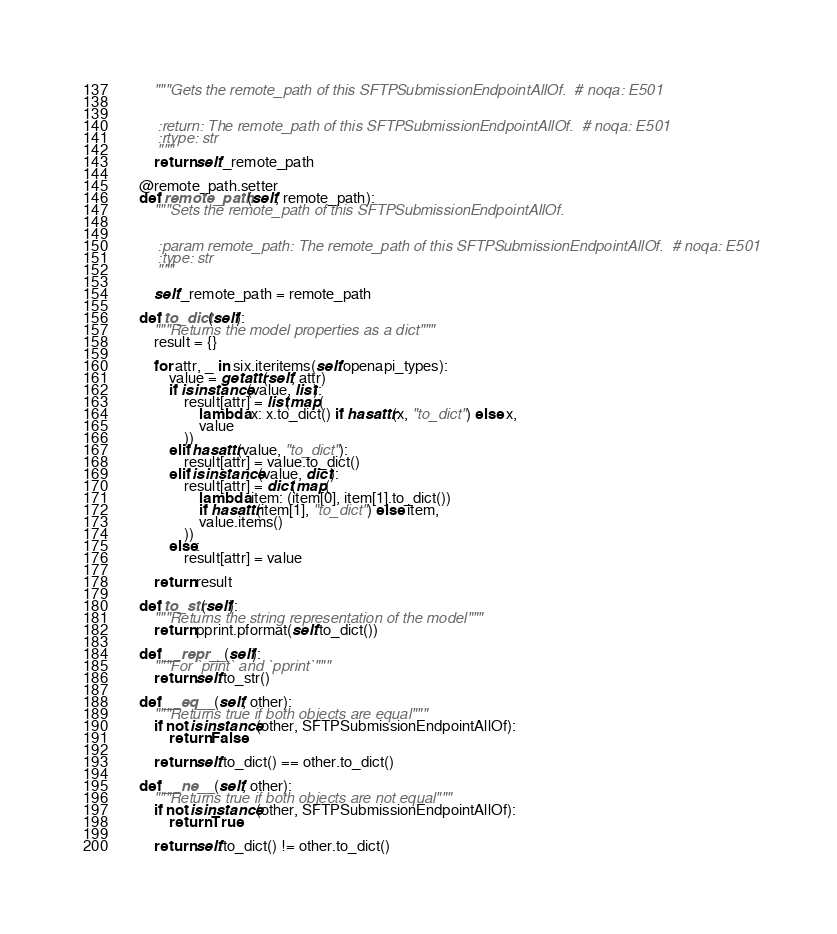<code> <loc_0><loc_0><loc_500><loc_500><_Python_>        """Gets the remote_path of this SFTPSubmissionEndpointAllOf.  # noqa: E501


        :return: The remote_path of this SFTPSubmissionEndpointAllOf.  # noqa: E501
        :rtype: str
        """
        return self._remote_path

    @remote_path.setter
    def remote_path(self, remote_path):
        """Sets the remote_path of this SFTPSubmissionEndpointAllOf.


        :param remote_path: The remote_path of this SFTPSubmissionEndpointAllOf.  # noqa: E501
        :type: str
        """

        self._remote_path = remote_path

    def to_dict(self):
        """Returns the model properties as a dict"""
        result = {}

        for attr, _ in six.iteritems(self.openapi_types):
            value = getattr(self, attr)
            if isinstance(value, list):
                result[attr] = list(map(
                    lambda x: x.to_dict() if hasattr(x, "to_dict") else x,
                    value
                ))
            elif hasattr(value, "to_dict"):
                result[attr] = value.to_dict()
            elif isinstance(value, dict):
                result[attr] = dict(map(
                    lambda item: (item[0], item[1].to_dict())
                    if hasattr(item[1], "to_dict") else item,
                    value.items()
                ))
            else:
                result[attr] = value

        return result

    def to_str(self):
        """Returns the string representation of the model"""
        return pprint.pformat(self.to_dict())

    def __repr__(self):
        """For `print` and `pprint`"""
        return self.to_str()

    def __eq__(self, other):
        """Returns true if both objects are equal"""
        if not isinstance(other, SFTPSubmissionEndpointAllOf):
            return False

        return self.to_dict() == other.to_dict()

    def __ne__(self, other):
        """Returns true if both objects are not equal"""
        if not isinstance(other, SFTPSubmissionEndpointAllOf):
            return True

        return self.to_dict() != other.to_dict()
</code> 